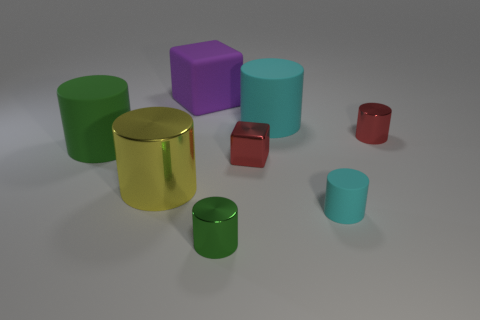Does the green thing that is left of the purple object have the same shape as the large purple object?
Provide a succinct answer. No. There is another object that is the same shape as the purple rubber object; what is its material?
Provide a succinct answer. Metal. Is the shape of the large purple object the same as the green object in front of the red block?
Offer a very short reply. No. The big matte object that is on the left side of the small metal block and in front of the large purple object is what color?
Your answer should be compact. Green. Are any yellow objects visible?
Keep it short and to the point. Yes. Is the number of purple blocks that are behind the big cyan cylinder the same as the number of large rubber cubes?
Offer a very short reply. Yes. What number of other objects are the same shape as the tiny matte object?
Provide a succinct answer. 5. What is the shape of the large purple rubber thing?
Your answer should be compact. Cube. Do the small cube and the red cylinder have the same material?
Provide a succinct answer. Yes. Are there the same number of tiny cyan matte cylinders that are left of the large cyan object and green cylinders that are behind the green metal thing?
Offer a very short reply. No. 